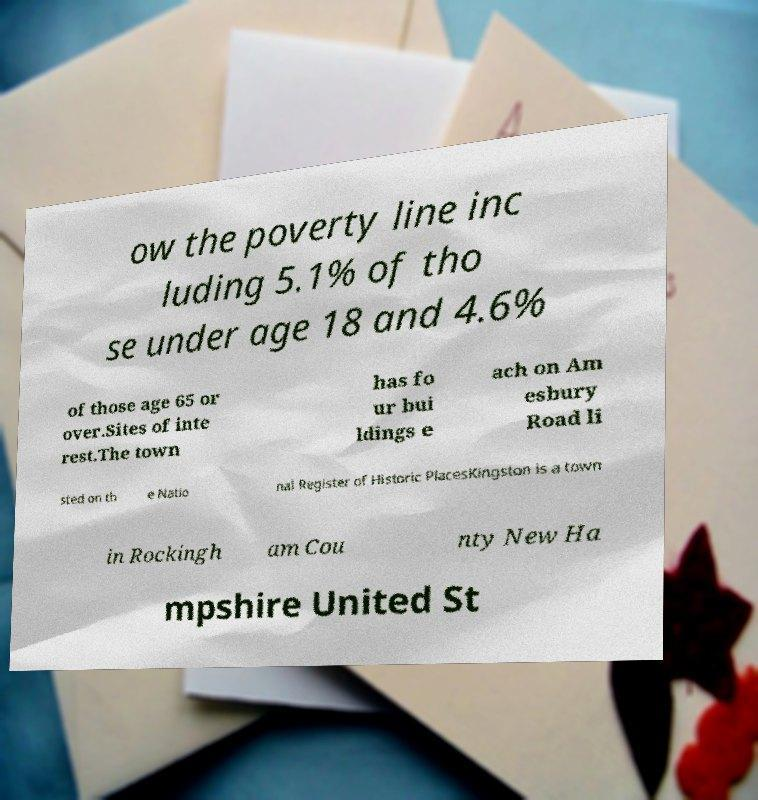What messages or text are displayed in this image? I need them in a readable, typed format. ow the poverty line inc luding 5.1% of tho se under age 18 and 4.6% of those age 65 or over.Sites of inte rest.The town has fo ur bui ldings e ach on Am esbury Road li sted on th e Natio nal Register of Historic PlacesKingston is a town in Rockingh am Cou nty New Ha mpshire United St 